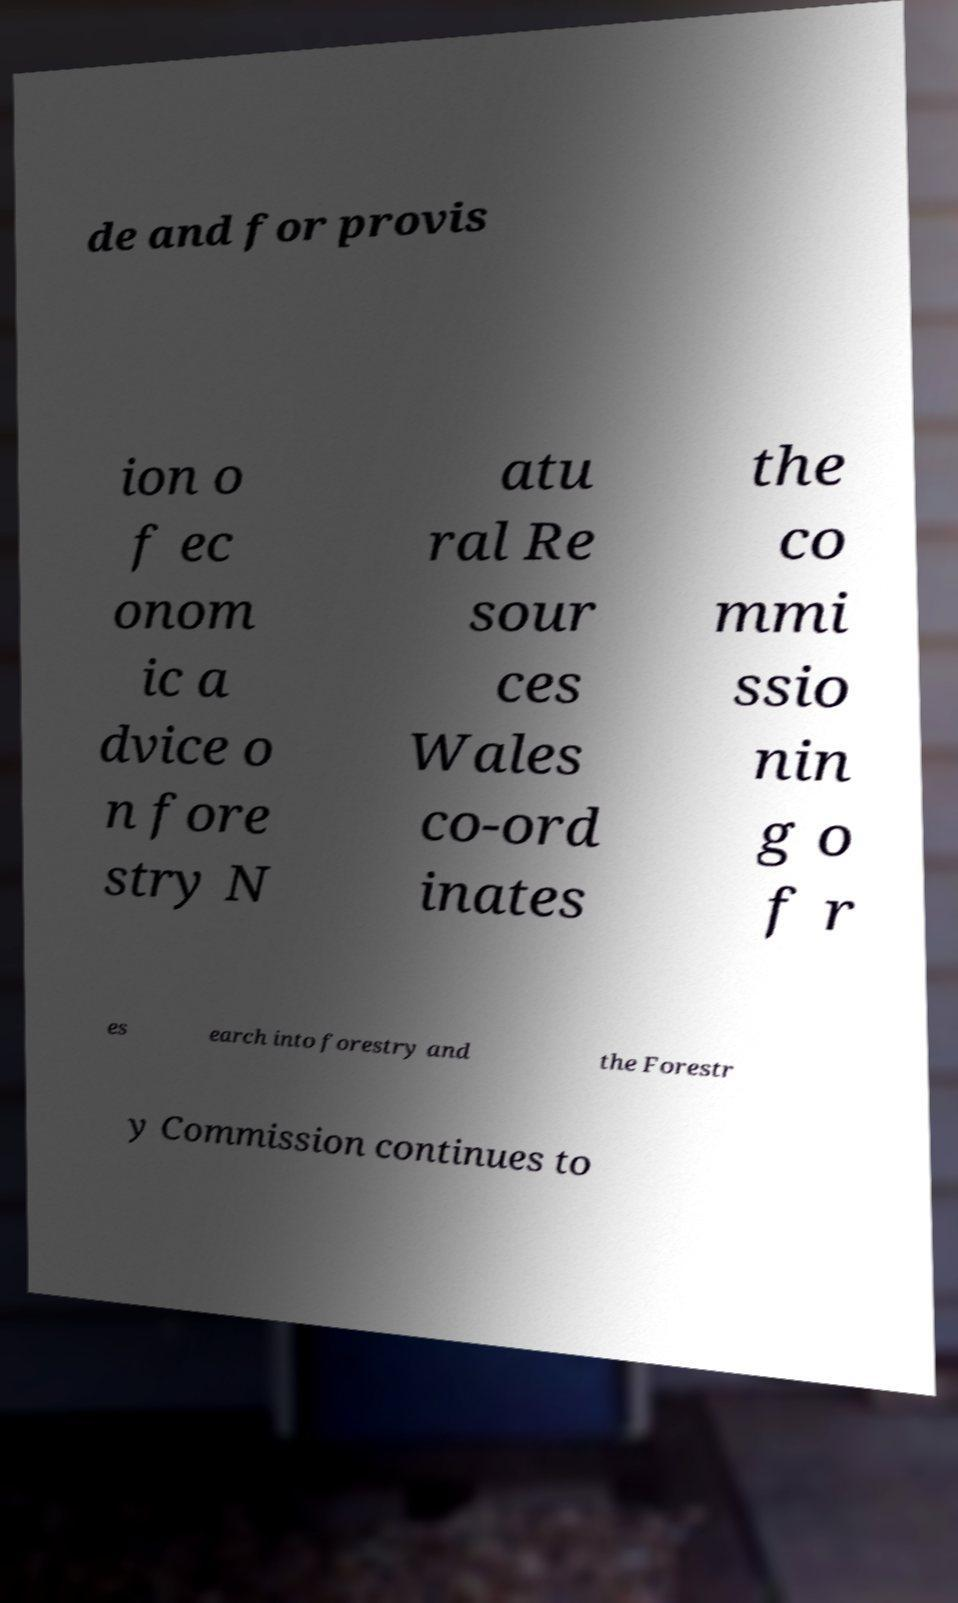Could you extract and type out the text from this image? de and for provis ion o f ec onom ic a dvice o n fore stry N atu ral Re sour ces Wales co-ord inates the co mmi ssio nin g o f r es earch into forestry and the Forestr y Commission continues to 